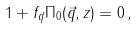<formula> <loc_0><loc_0><loc_500><loc_500>1 + f _ { \vec { q } } \Pi _ { 0 } ( { \vec { q } } , z ) = 0 \, ,</formula> 